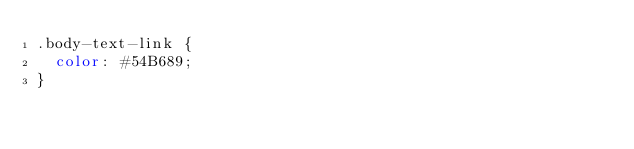<code> <loc_0><loc_0><loc_500><loc_500><_CSS_>.body-text-link {
  color: #54B689;
}</code> 